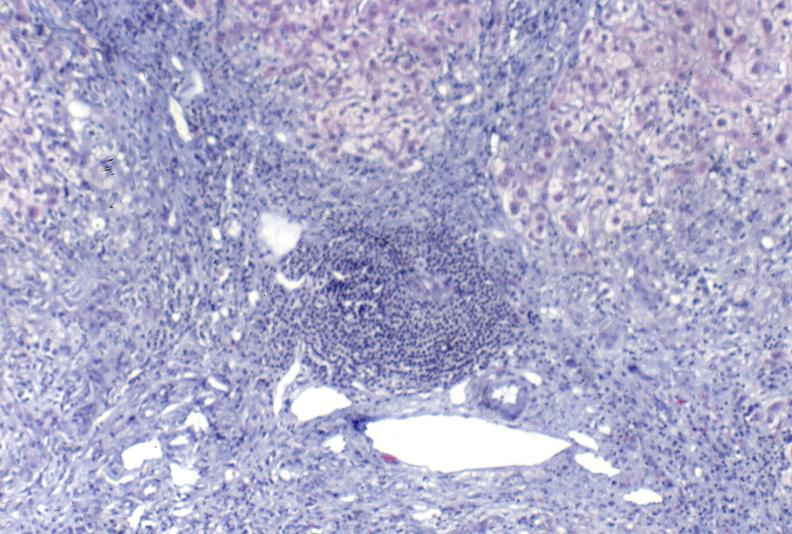does this image show primary biliary cirrhosis?
Answer the question using a single word or phrase. Yes 